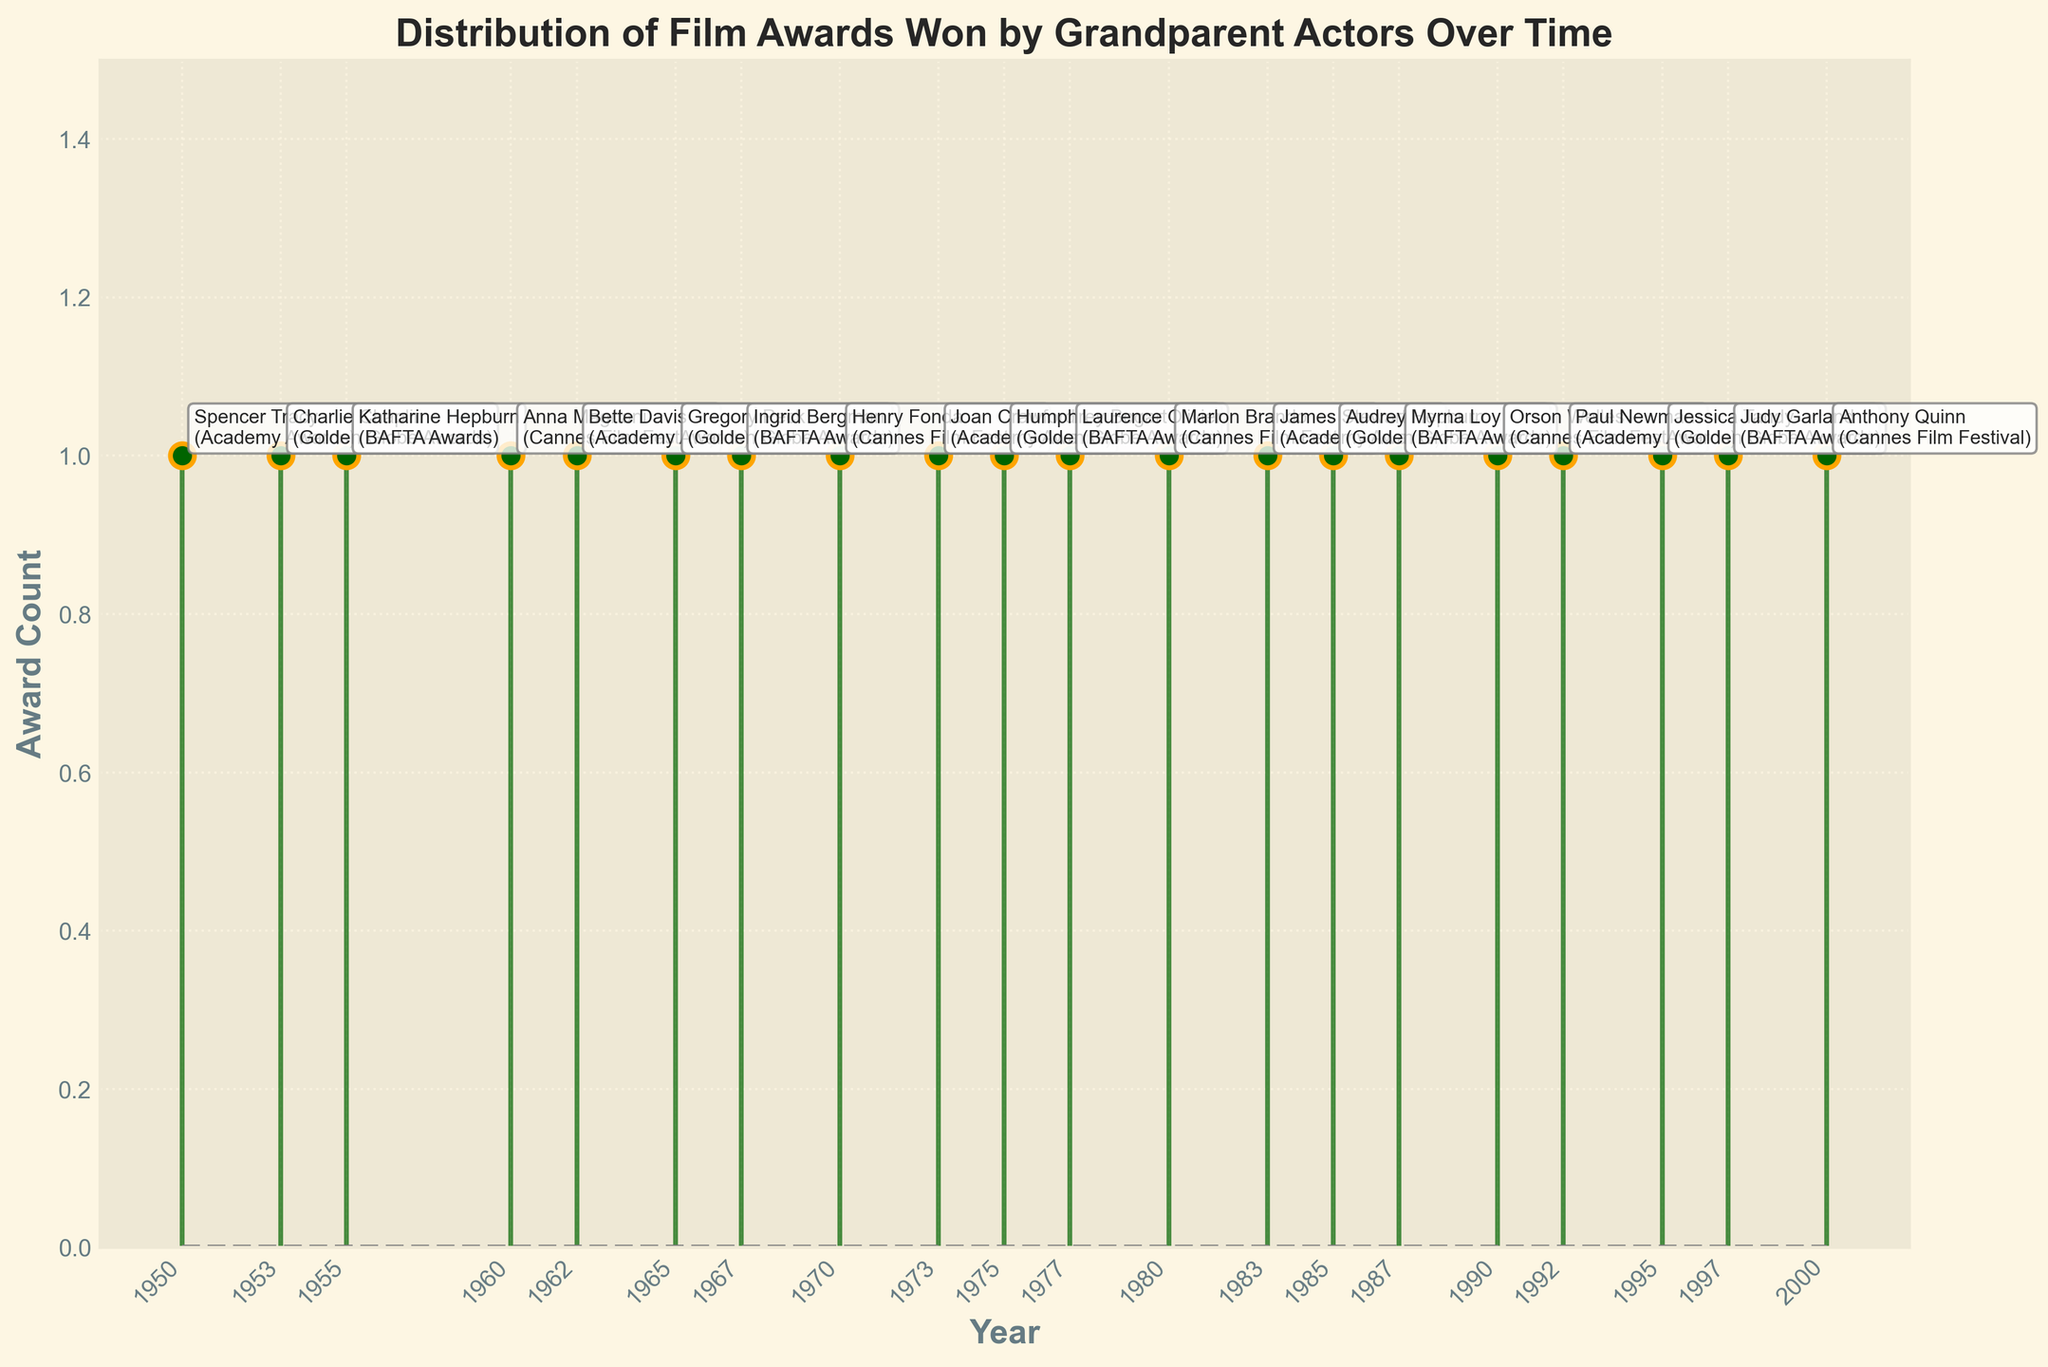How many total data points are plotted in the figure? Count the number of markers on the stem plot; each marker represents a data point.
Answer: 20 What is the title of the figure? Read the text at the top center of the figure.
Answer: Distribution of Film Awards Won by Grandparent Actors Over Time Which year had the highest number of awards noted in the plot? Observe the y-values of the stem lines to find the highest value, which is 1 in every case; since all awards count is 1, you can select any year.
Answer: 1950 (or any other year) Which actor is annotated next to the marker in 1962? Look at the annotation next to the 1962 marker.
Answer: Bette Davis How many years are represented on the x-axis? Count the number of distinct years labeled on the x-axis.
Answer: 20 Which year had a Cannes Film Festival award? Identify the years with annotations showing '(Cannes Film Festival)'.
Answer: 1960, 1970, 1980, 1990, 2000 How many Academy Awards were won according to the plot? Count the number of annotations mentioning '(Academy Awards)'.
Answer: 5 In which year did Katherine Hepburn win an award, and what type of award was it? Look at the annotations to find Katherine Hepburn and note the year and award type.
Answer: 1955, BAFTA Awards What is the average award count per year? Since each year has exactly one award, the average is simply 1.0 (Sum of award counts: 20, divided by number of years: 20).
Answer: 1.0 Are there more awards won in the 1950s or the 1980s? Count the awards in each decade and compare. The 1950s has 3 awards (1950, 1953, 1955) and the 1980s has 3 awards (1980, 1983, 1985).
Answer: Equal 